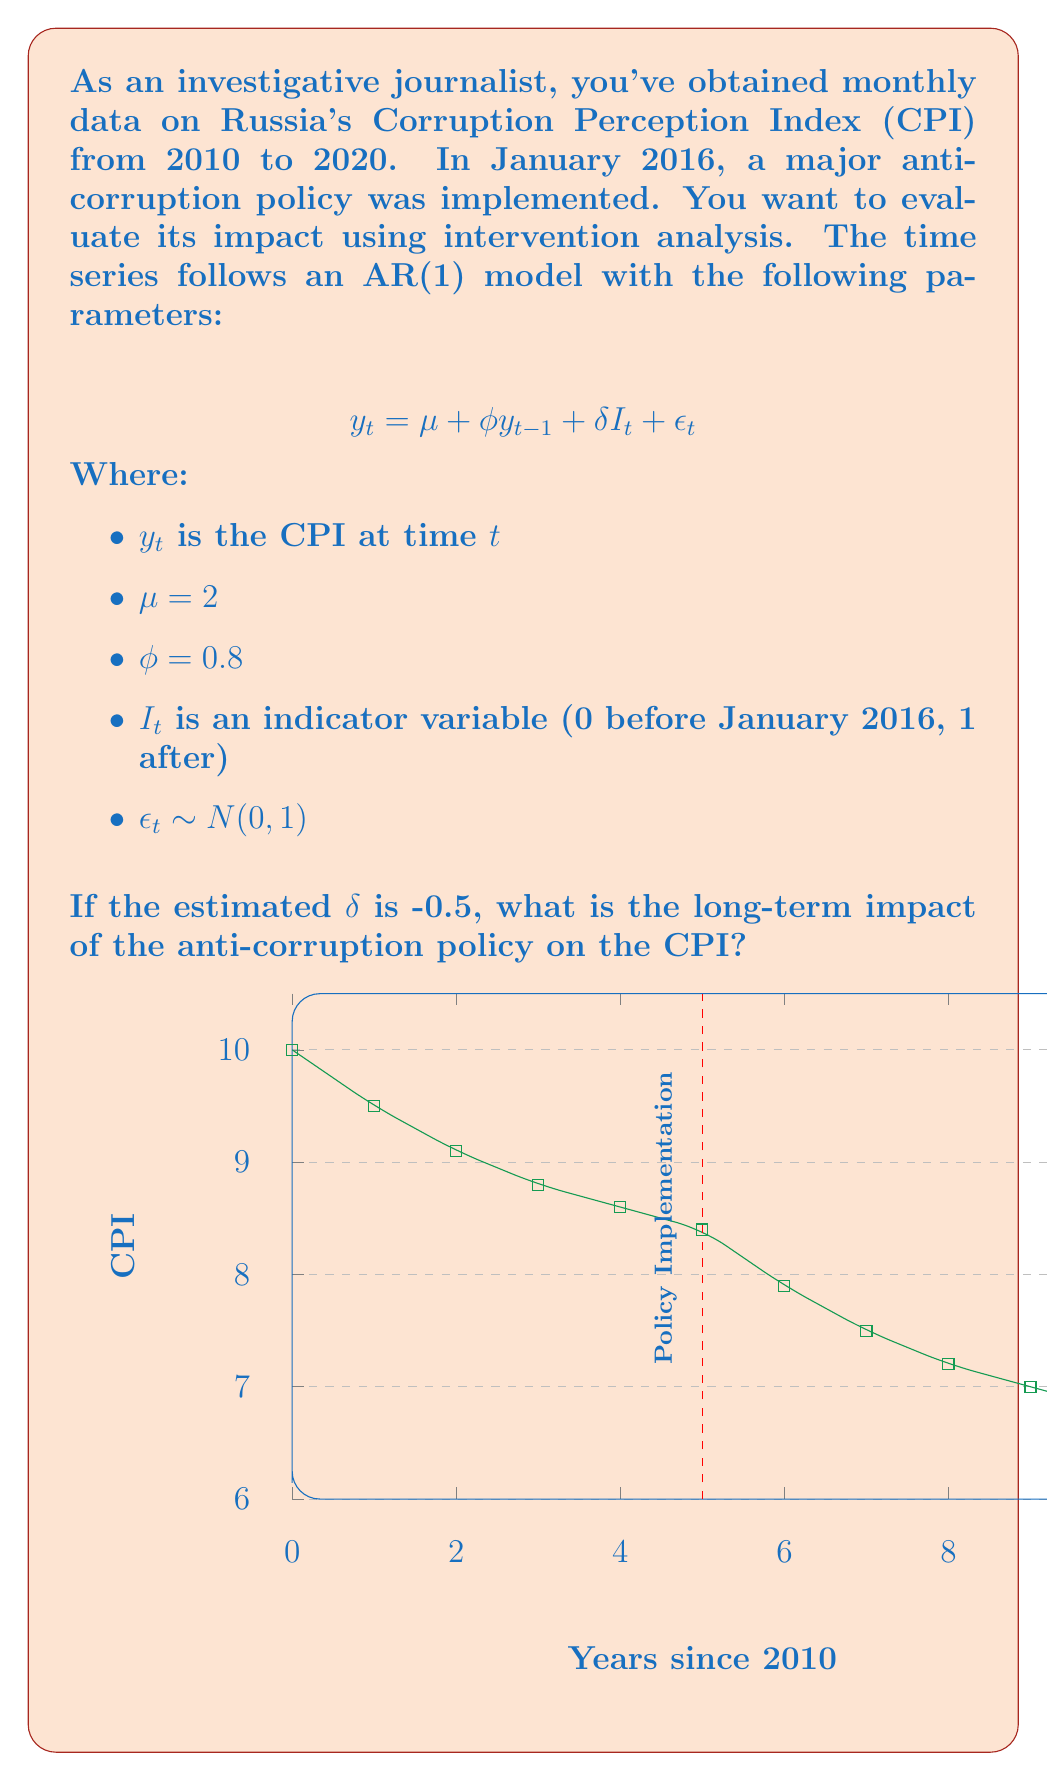Can you answer this question? To determine the long-term impact of the anti-corruption policy on the CPI, we need to calculate the difference between the steady-state levels before and after the intervention. Let's approach this step-by-step:

1) The steady-state level before the intervention (when $I_t = 0$) is given by:

   $$ E[y_t] = \mu + \phi E[y_t] $$
   $$ E[y_t](1-\phi) = \mu $$
   $$ E[y_t] = \frac{\mu}{1-\phi} = \frac{2}{1-0.8} = 10 $$

2) After the intervention (when $I_t = 1$), the new steady-state level is:

   $$ E[y_t] = \mu + \phi E[y_t] + \delta $$
   $$ E[y_t](1-\phi) = \mu + \delta $$
   $$ E[y_t] = \frac{\mu + \delta}{1-\phi} = \frac{2 + (-0.5)}{1-0.8} = \frac{1.5}{0.2} = 7.5 $$

3) The long-term impact is the difference between these two steady-state levels:

   $$ \text{Long-term impact} = 7.5 - 10 = -2.5 $$

Therefore, the long-term impact of the anti-corruption policy is a decrease of 2.5 points in the Corruption Perception Index.
Answer: -2.5 